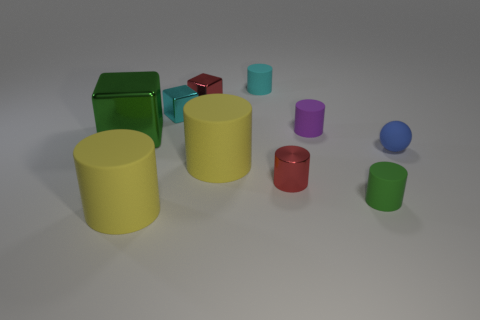What might be the context or purpose of these items? These objects appear to be simple geometric shapes typically used for educational purposes or as part of a computer graphics test scene for rendering and lighting demonstrations. Do they seem to be arranged in a specific pattern or randomly placed? Their arrangement seems quite random, with no apparent pattern or organization. It looks like they were scattered casually across the surface. 